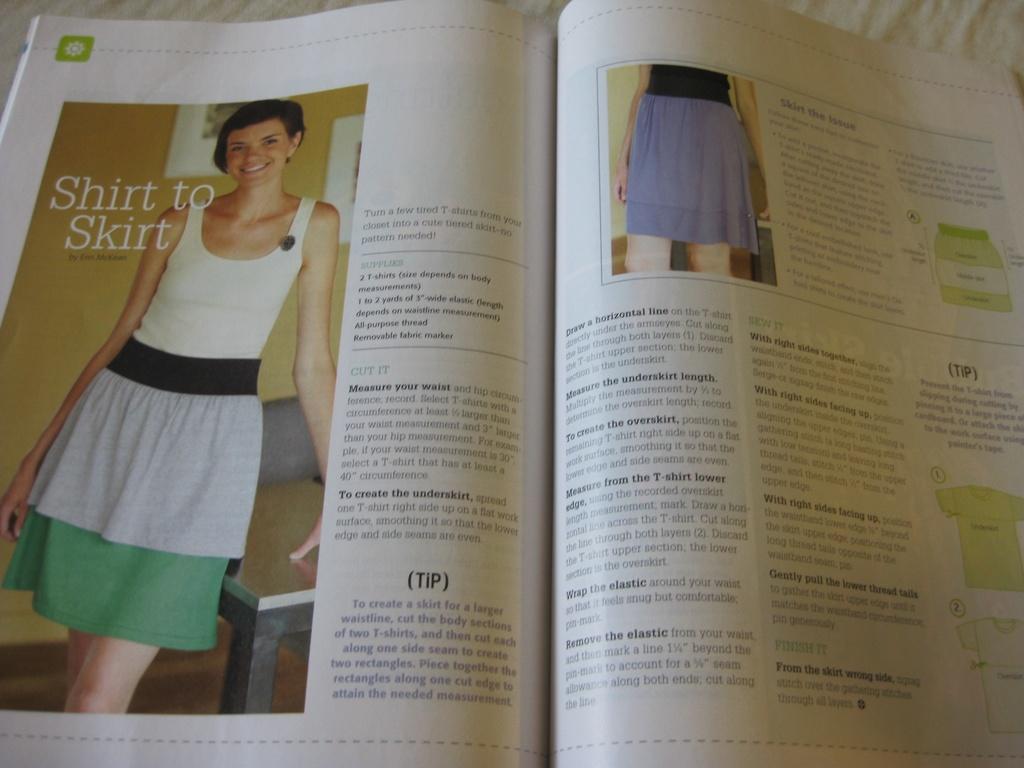The article topic is about what clothing items?
Your response must be concise. Skirts. What is the name of the article?
Provide a short and direct response. Shirt to skirt. 